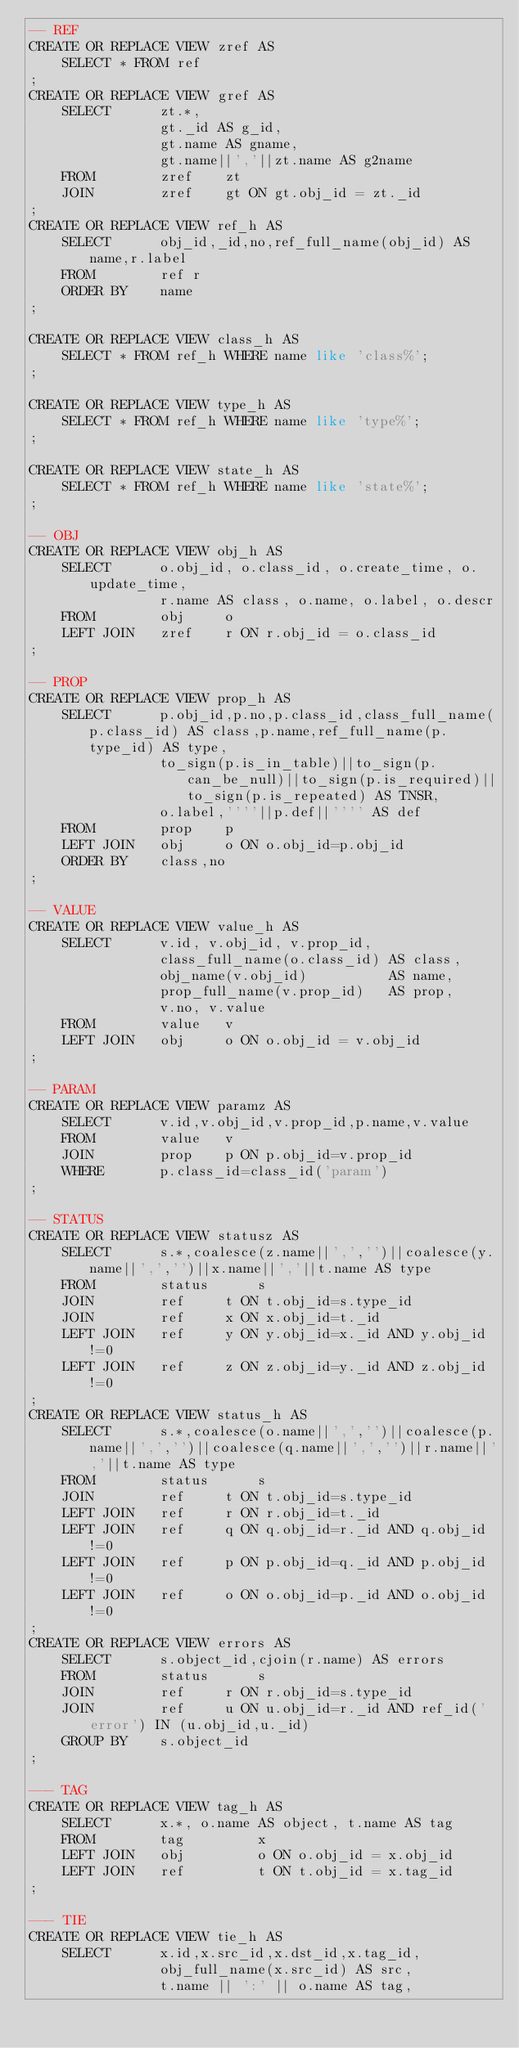<code> <loc_0><loc_0><loc_500><loc_500><_SQL_>-- REF
CREATE OR REPLACE VIEW zref AS
    SELECT * FROM ref
;
CREATE OR REPLACE VIEW gref AS
    SELECT      zt.*,
                gt._id AS g_id,
                gt.name AS gname,
                gt.name||','||zt.name AS g2name
    FROM        zref    zt
    JOIN        zref    gt ON gt.obj_id = zt._id
;
CREATE OR REPLACE VIEW ref_h AS
    SELECT      obj_id,_id,no,ref_full_name(obj_id) AS name,r.label
    FROM        ref r
    ORDER BY    name
;

CREATE OR REPLACE VIEW class_h AS
    SELECT * FROM ref_h WHERE name like 'class%';
;

CREATE OR REPLACE VIEW type_h AS
    SELECT * FROM ref_h WHERE name like 'type%';
;

CREATE OR REPLACE VIEW state_h AS
    SELECT * FROM ref_h WHERE name like 'state%';
;

-- OBJ
CREATE OR REPLACE VIEW obj_h AS
    SELECT      o.obj_id, o.class_id, o.create_time, o.update_time,
                r.name AS class, o.name, o.label, o.descr
    FROM        obj     o
    LEFT JOIN   zref    r ON r.obj_id = o.class_id
;

-- PROP
CREATE OR REPLACE VIEW prop_h AS
    SELECT      p.obj_id,p.no,p.class_id,class_full_name(p.class_id) AS class,p.name,ref_full_name(p.type_id) AS type,
                to_sign(p.is_in_table)||to_sign(p.can_be_null)||to_sign(p.is_required)||to_sign(p.is_repeated) AS TNSR,
                o.label,''''||p.def||'''' AS def
    FROM        prop    p
    LEFT JOIN   obj     o ON o.obj_id=p.obj_id
    ORDER BY    class,no
;

-- VALUE
CREATE OR REPLACE VIEW value_h AS
    SELECT      v.id, v.obj_id, v.prop_id,
                class_full_name(o.class_id) AS class,
                obj_name(v.obj_id)          AS name,
                prop_full_name(v.prop_id)   AS prop,
                v.no, v.value
    FROM        value   v
    LEFT JOIN   obj     o ON o.obj_id = v.obj_id
;

-- PARAM
CREATE OR REPLACE VIEW paramz AS
    SELECT      v.id,v.obj_id,v.prop_id,p.name,v.value
    FROM        value   v
    JOIN        prop    p ON p.obj_id=v.prop_id
    WHERE       p.class_id=class_id('param')
;

-- STATUS
CREATE OR REPLACE VIEW statusz AS
    SELECT      s.*,coalesce(z.name||',','')||coalesce(y.name||',','')||x.name||','||t.name AS type
    FROM        status      s
    JOIN        ref     t ON t.obj_id=s.type_id
    JOIN        ref     x ON x.obj_id=t._id
    LEFT JOIN   ref     y ON y.obj_id=x._id AND y.obj_id!=0
    LEFT JOIN   ref     z ON z.obj_id=y._id AND z.obj_id!=0
;
CREATE OR REPLACE VIEW status_h AS
    SELECT      s.*,coalesce(o.name||',','')||coalesce(p.name||',','')||coalesce(q.name||',','')||r.name||','||t.name AS type
    FROM        status      s
    JOIN        ref     t ON t.obj_id=s.type_id
    LEFT JOIN   ref     r ON r.obj_id=t._id
    LEFT JOIN   ref     q ON q.obj_id=r._id AND q.obj_id!=0
    LEFT JOIN   ref     p ON p.obj_id=q._id AND p.obj_id!=0
    LEFT JOIN   ref     o ON o.obj_id=p._id AND o.obj_id!=0
;
CREATE OR REPLACE VIEW errors AS
    SELECT      s.object_id,cjoin(r.name) AS errors
    FROM        status      s
    JOIN        ref     r ON r.obj_id=s.type_id
    JOIN        ref     u ON u.obj_id=r._id AND ref_id('error') IN (u.obj_id,u._id)
    GROUP BY    s.object_id
;

--- TAG
CREATE OR REPLACE VIEW tag_h AS
    SELECT      x.*, o.name AS object, t.name AS tag
    FROM        tag         x
    LEFT JOIN   obj         o ON o.obj_id = x.obj_id
    LEFT JOIN   ref         t ON t.obj_id = x.tag_id
;

--- TIE
CREATE OR REPLACE VIEW tie_h AS
    SELECT      x.id,x.src_id,x.dst_id,x.tag_id,
                obj_full_name(x.src_id) AS src,
                t.name || ':' || o.name AS tag,</code> 